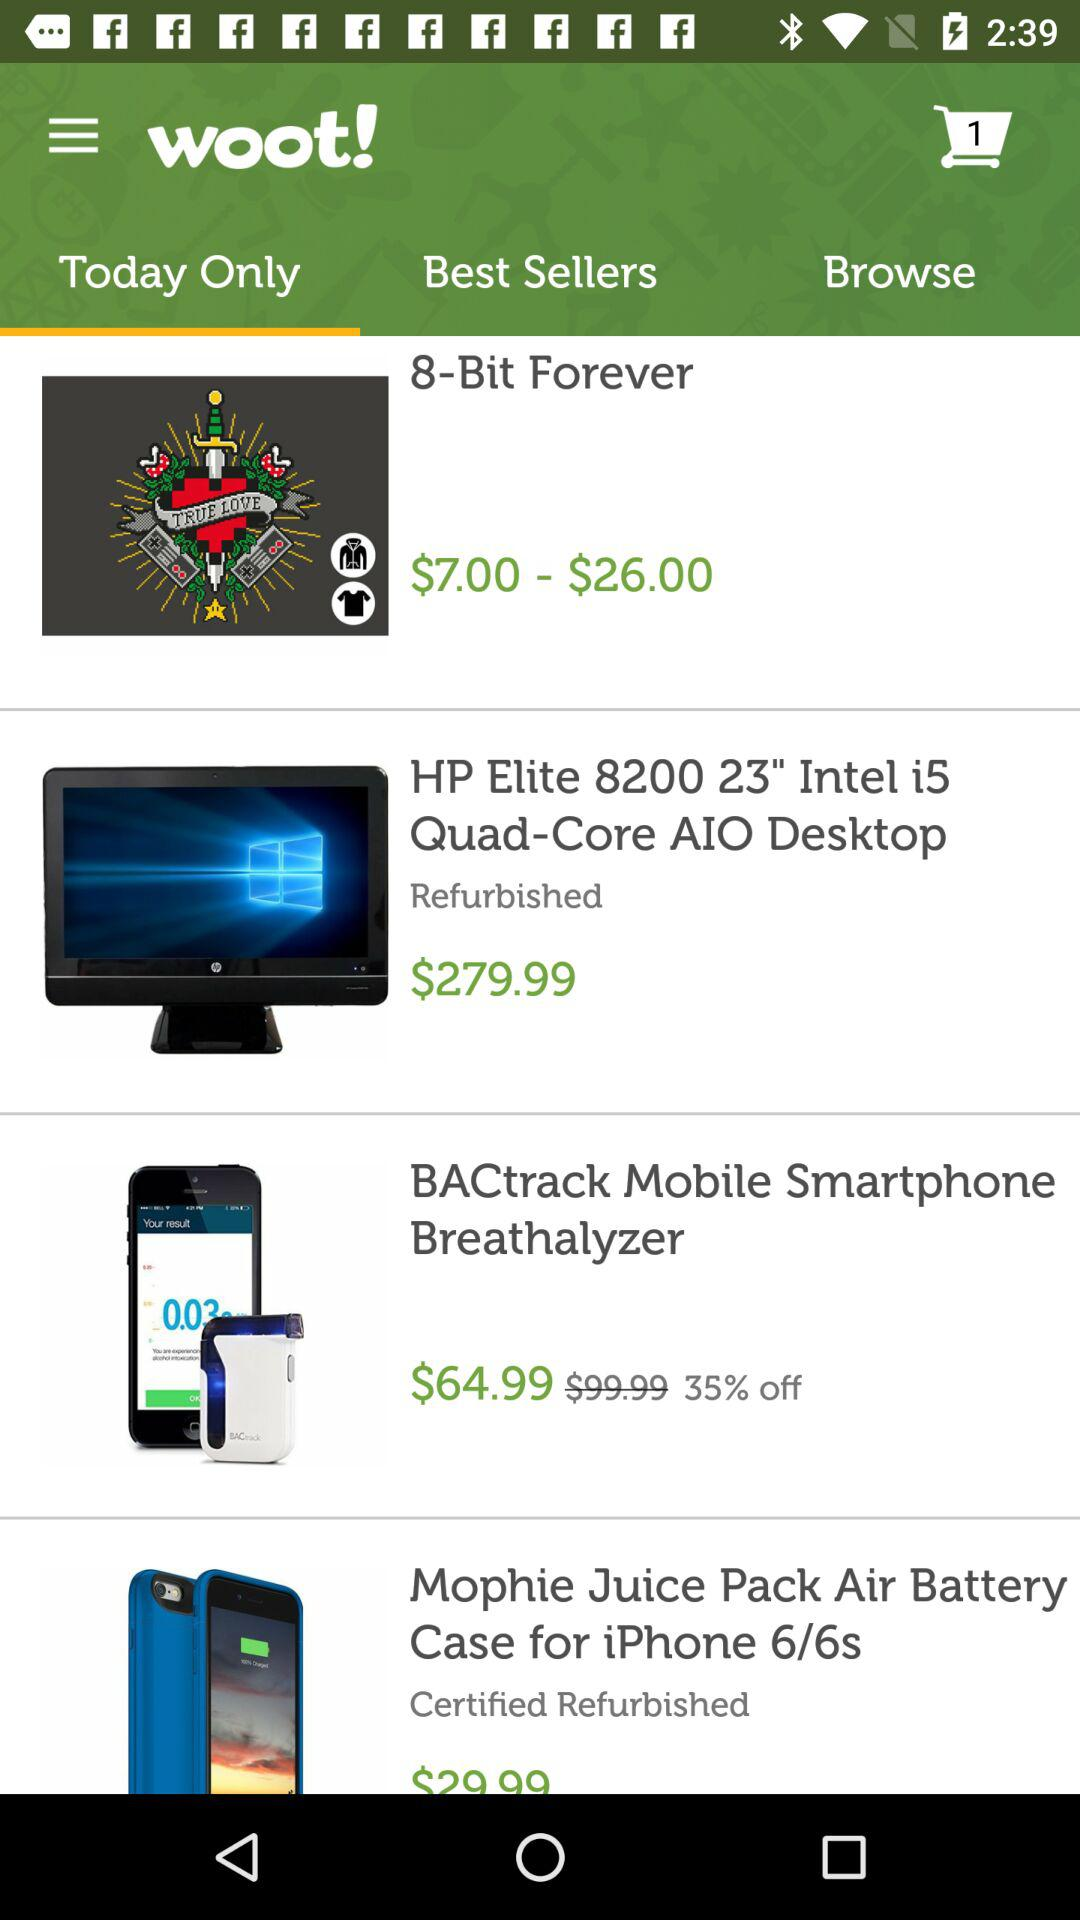What is the price range for "8-Bit Forever"? The price for "8-Bit Forever" ranges from $7.00 to $26.00. 